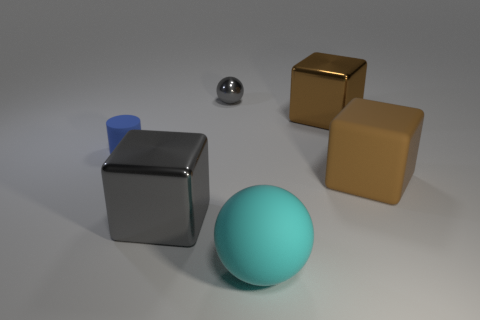Is there anything else that has the same color as the large ball?
Offer a very short reply. No. There is a cube that is the same material as the large cyan sphere; what is its size?
Keep it short and to the point. Large. What is the shape of the thing that is right of the big matte ball and behind the brown rubber object?
Your response must be concise. Cube. Does the metallic thing that is in front of the blue matte object have the same color as the small metal thing?
Offer a very short reply. Yes. Does the large metallic thing to the left of the small gray metal object have the same shape as the small thing that is to the right of the large gray object?
Make the answer very short. No. There is a blue cylinder that is behind the large gray metal object; what size is it?
Your answer should be compact. Small. There is a gray metal object that is on the right side of the block that is left of the rubber sphere; how big is it?
Provide a succinct answer. Small. Are there more large gray cubes than big red metal cylinders?
Make the answer very short. Yes. Is the number of tiny gray shiny spheres that are behind the large gray thing greater than the number of big brown cubes in front of the big rubber block?
Keep it short and to the point. Yes. How big is the shiny thing that is both left of the large matte ball and behind the large gray metallic object?
Your response must be concise. Small. 